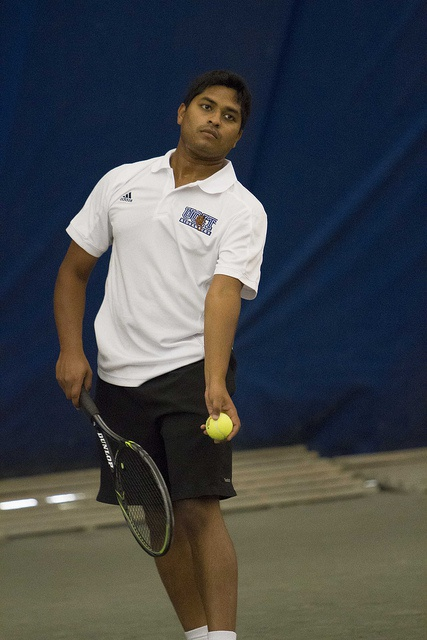Describe the objects in this image and their specific colors. I can see people in black, lightgray, and maroon tones, tennis racket in black, gray, and darkgreen tones, and sports ball in black, khaki, and olive tones in this image. 